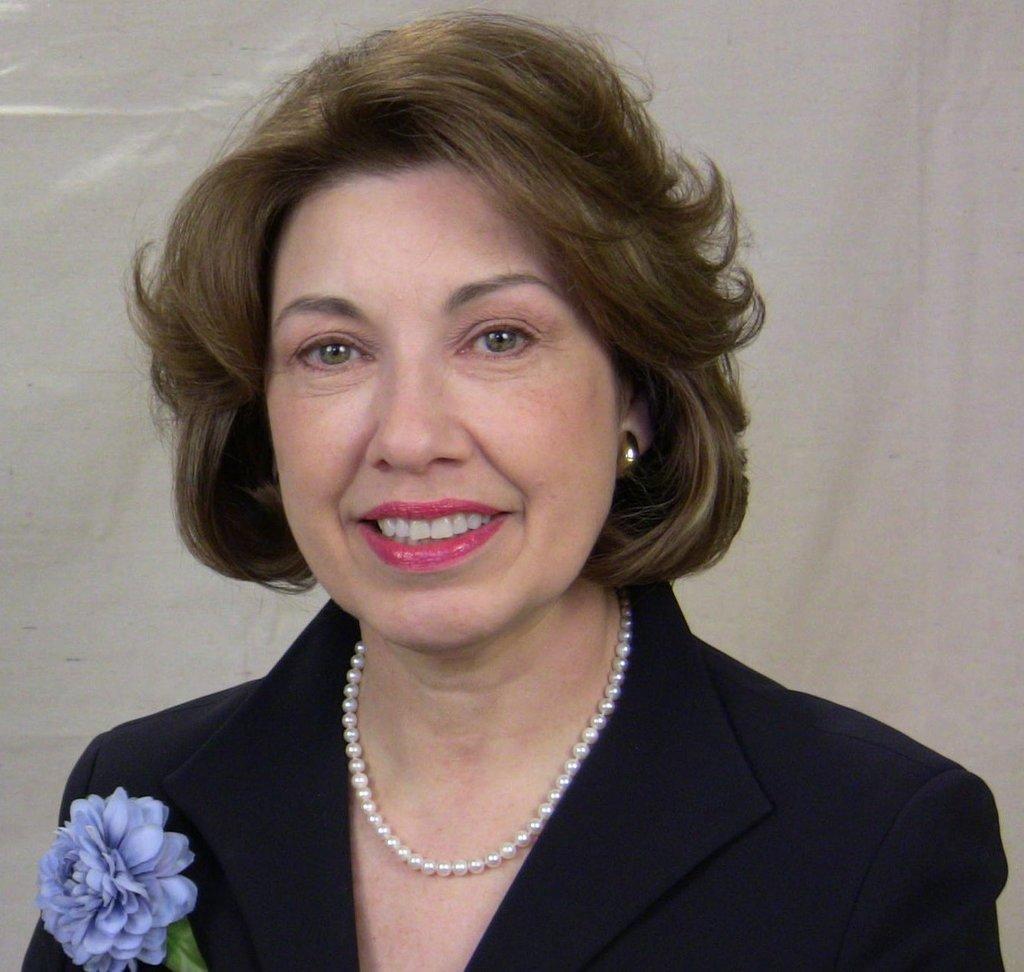Describe this image in one or two sentences. As we can see in the image there is a woman wearing black color dress and there is a flower. 